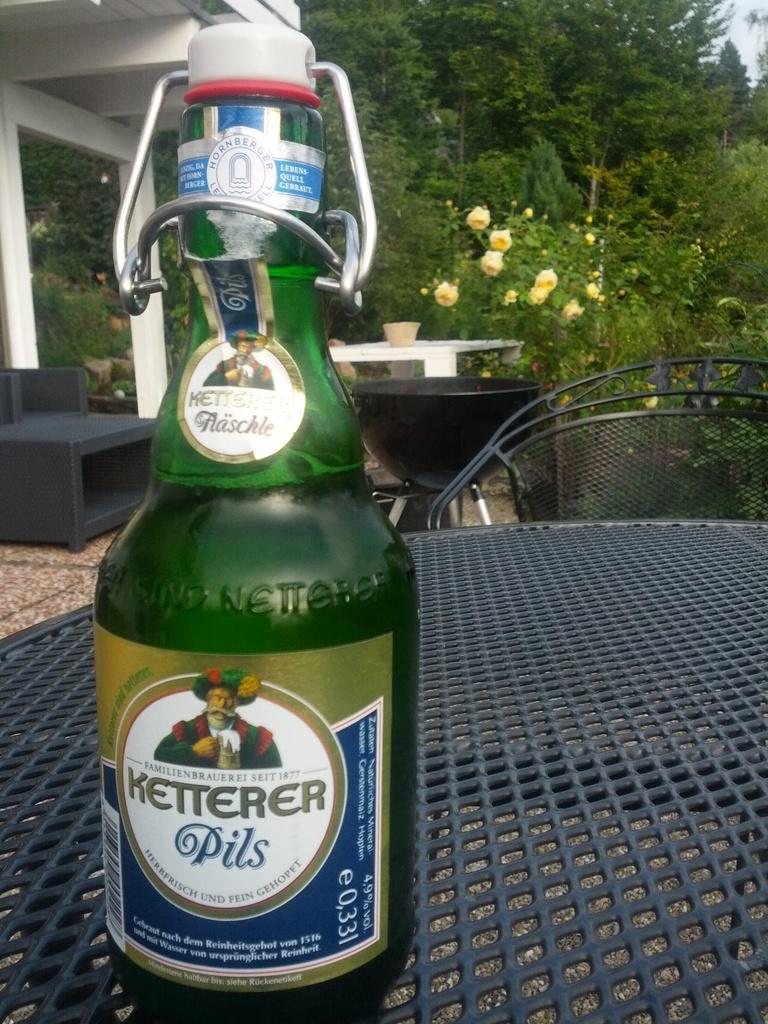What kind of beer is in tht bottle?
Offer a very short reply. Ketterer pils. 